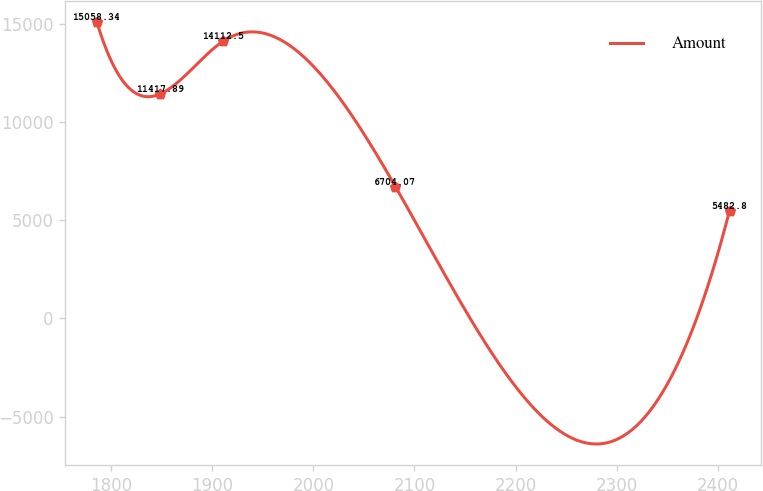<chart> <loc_0><loc_0><loc_500><loc_500><line_chart><ecel><fcel>Amount<nl><fcel>1785.83<fcel>15058.3<nl><fcel>1848.42<fcel>11417.9<nl><fcel>1911.01<fcel>14112.5<nl><fcel>2081.13<fcel>6704.07<nl><fcel>2411.77<fcel>5482.8<nl></chart> 